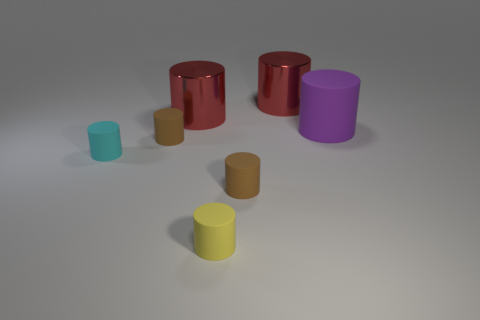Are there any purple things that have the same material as the yellow cylinder?
Your response must be concise. Yes. The big rubber cylinder has what color?
Provide a short and direct response. Purple. There is a metal thing that is left of the yellow thing; is its shape the same as the yellow rubber thing?
Your response must be concise. Yes. The red thing left of the red cylinder to the right of the tiny object that is on the right side of the small yellow rubber cylinder is what shape?
Give a very brief answer. Cylinder. What is the tiny brown object in front of the cyan rubber object made of?
Your answer should be compact. Rubber. What number of other things are the same shape as the tiny yellow matte thing?
Make the answer very short. 6. Does the cyan rubber thing have the same size as the yellow cylinder?
Ensure brevity in your answer.  Yes. Are there more tiny brown things right of the small cyan cylinder than red metal cylinders that are on the left side of the small yellow rubber object?
Offer a very short reply. Yes. How many other objects are the same size as the cyan cylinder?
Make the answer very short. 3. Is the number of small rubber objects on the right side of the yellow cylinder greater than the number of big purple rubber blocks?
Your response must be concise. Yes. 